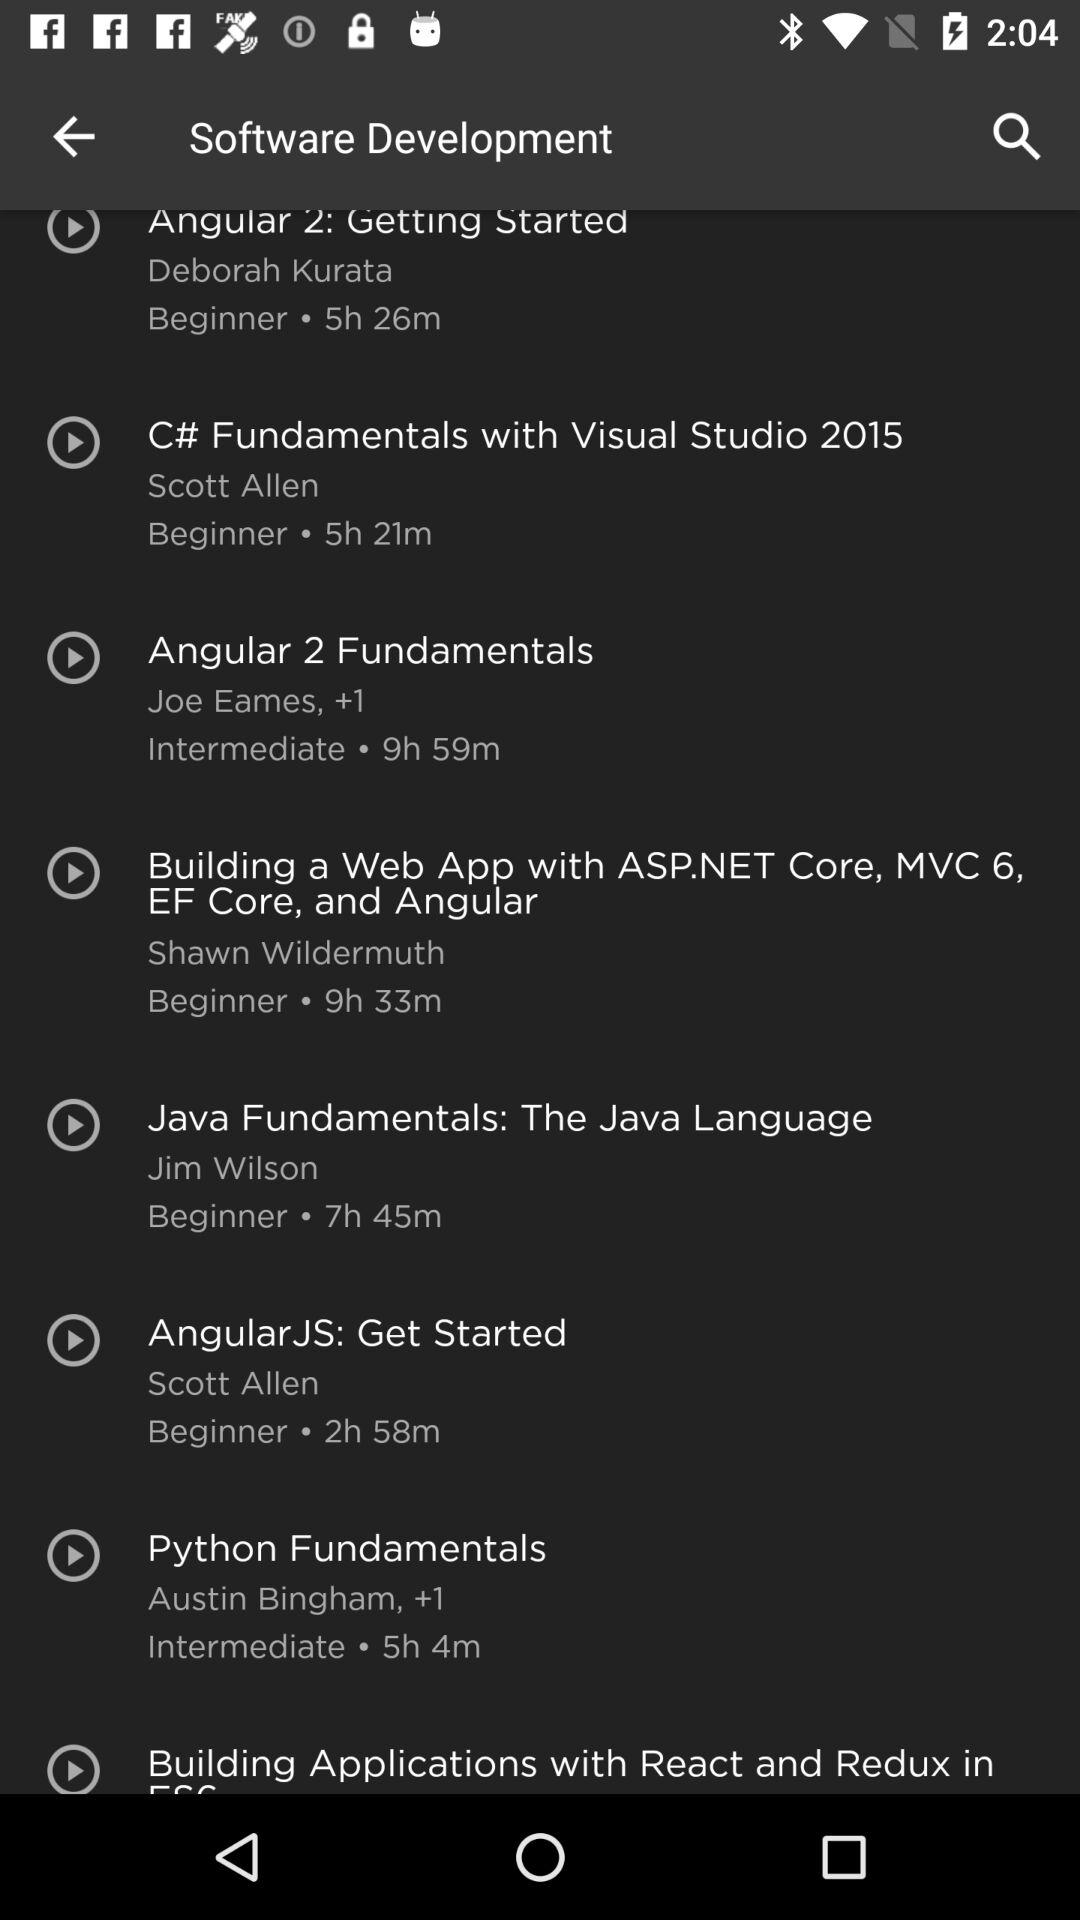What options are there for someone wanting to learn about JavaScript and Angular on this platform? For someone interested in JavaScript and Angular, two prominent options are 'Angular 2: Getting Started' by Deborah Kurata, a beginner-level course taking about 5 hours and 26 minutes, and 'Building a Web App with ASP.NET Core, MVC 6, EF Core, and Angular' by Shawn Wildermuth, which is a longer beginner-level course lasting 9 hours and 33 minutes. 